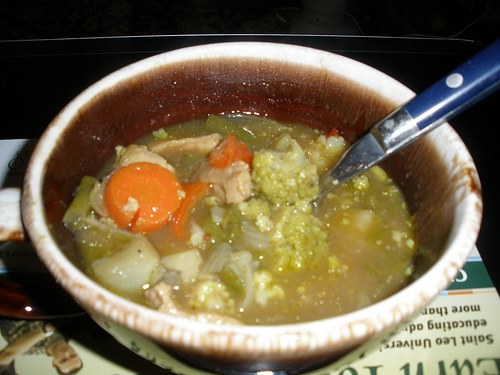Is there soup to the right of the carrot that looks oval? Yes, there is soup to the right of the oval-shaped carrot. 